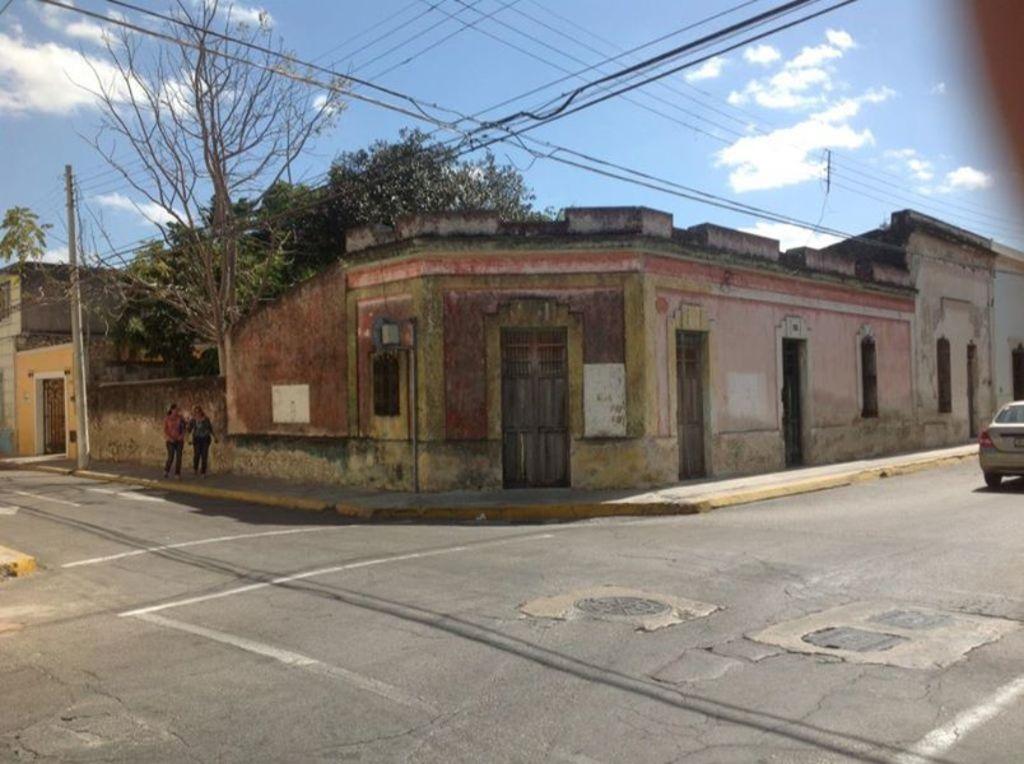Can you describe this image briefly? This image is taken outdoors. At the bottom of the image there is a road. On the right side of the image a car is moving on the road. At the top of the image there is a sky with clouds. In the middle of the image there is a building with walls, windows, doors, roof and a board with text on it. Two women are walking on the sidewalk. There are a few trees and a pole with wires. 